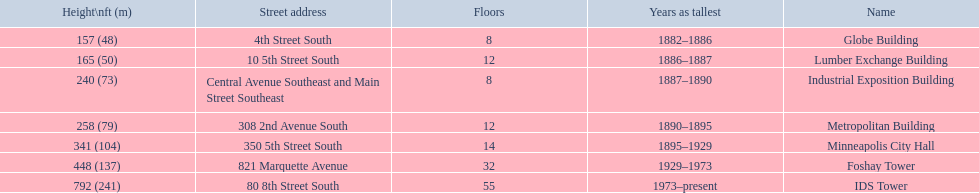What are the heights of the buildings? 157 (48), 165 (50), 240 (73), 258 (79), 341 (104), 448 (137), 792 (241). Can you parse all the data within this table? {'header': ['Height\\nft (m)', 'Street address', 'Floors', 'Years as tallest', 'Name'], 'rows': [['157 (48)', '4th Street South', '8', '1882–1886', 'Globe Building'], ['165 (50)', '10 5th Street South', '12', '1886–1887', 'Lumber Exchange Building'], ['240 (73)', 'Central Avenue Southeast and Main Street Southeast', '8', '1887–1890', 'Industrial Exposition Building'], ['258 (79)', '308 2nd Avenue South', '12', '1890–1895', 'Metropolitan Building'], ['341 (104)', '350 5th Street South', '14', '1895–1929', 'Minneapolis City Hall'], ['448 (137)', '821 Marquette Avenue', '32', '1929–1973', 'Foshay Tower'], ['792 (241)', '80 8th Street South', '55', '1973–present', 'IDS Tower']]} What building is 240 ft tall? Industrial Exposition Building. 